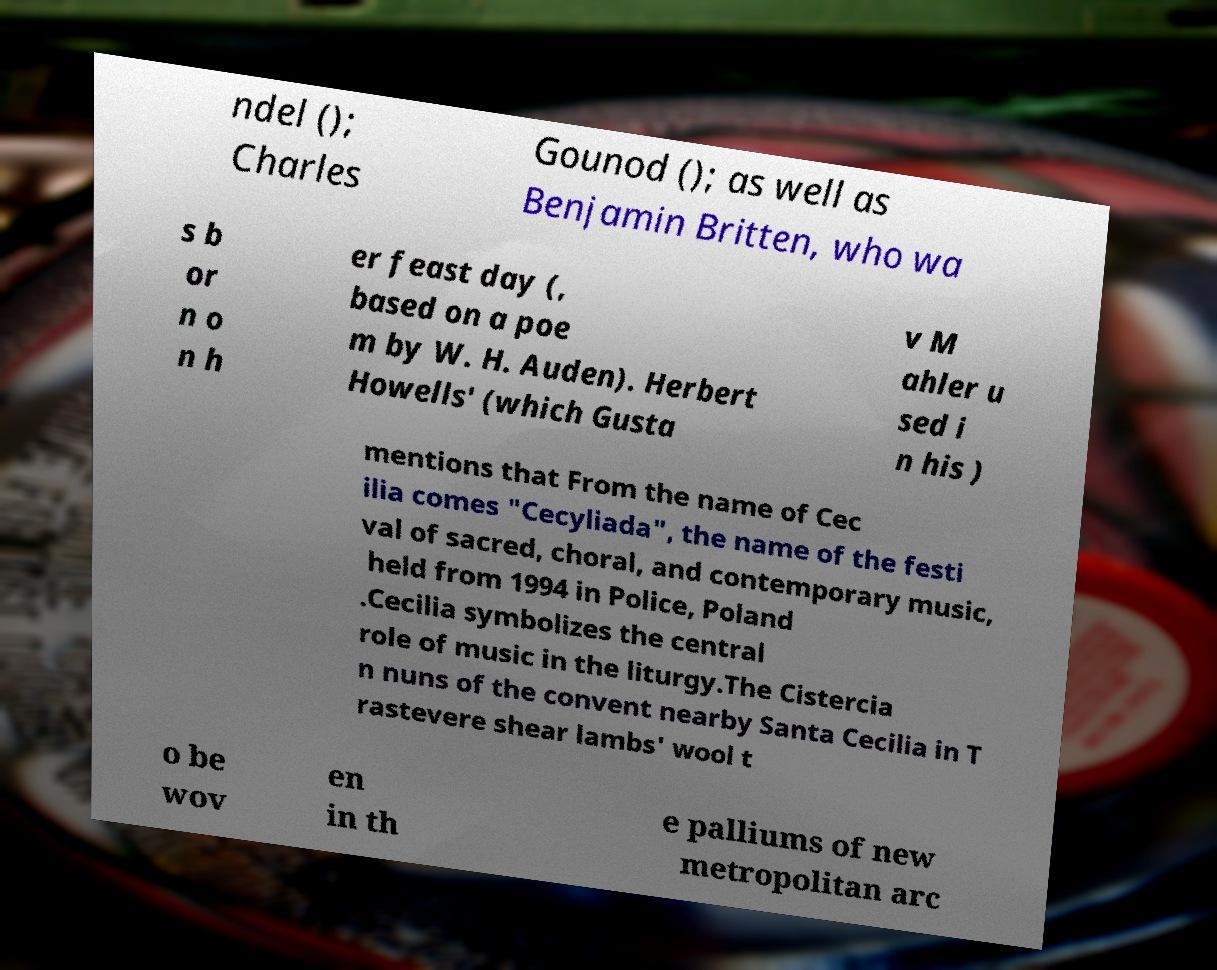Could you extract and type out the text from this image? ndel (); Charles Gounod (); as well as Benjamin Britten, who wa s b or n o n h er feast day (, based on a poe m by W. H. Auden). Herbert Howells' (which Gusta v M ahler u sed i n his ) mentions that From the name of Cec ilia comes "Cecyliada", the name of the festi val of sacred, choral, and contemporary music, held from 1994 in Police, Poland .Cecilia symbolizes the central role of music in the liturgy.The Cistercia n nuns of the convent nearby Santa Cecilia in T rastevere shear lambs' wool t o be wov en in th e palliums of new metropolitan arc 